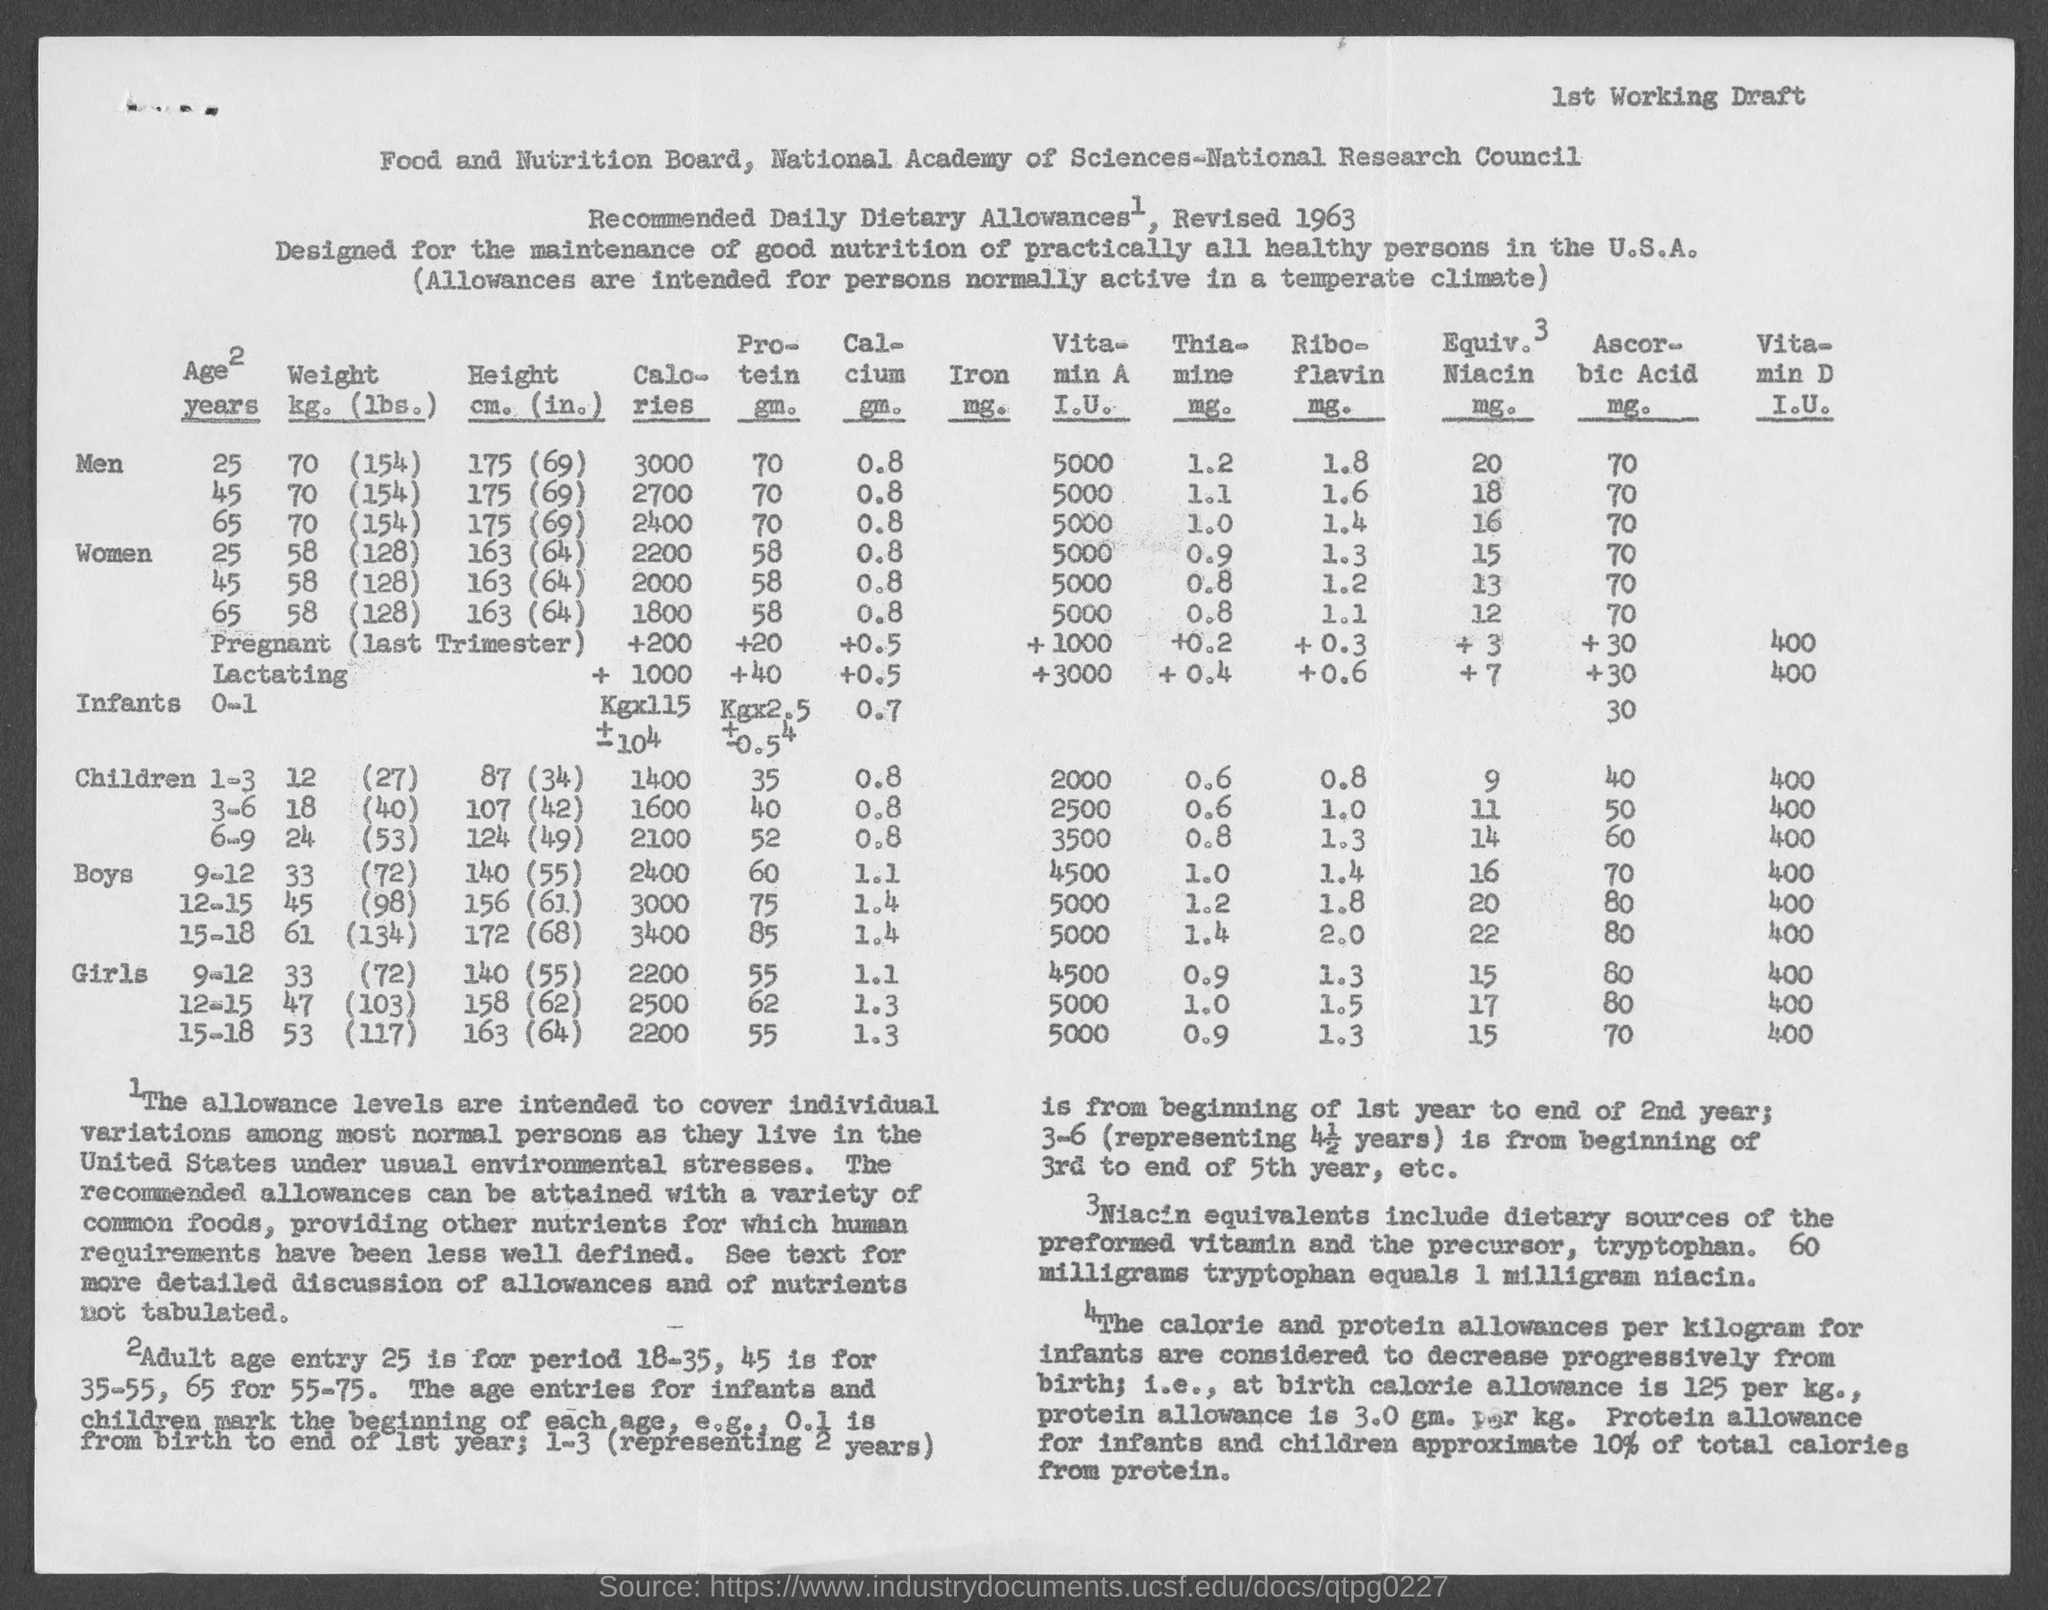Identify some key points in this picture. The revised "Recommended Daily Dietary Allowances" were published in 1963. The recommended amount of protein at birth is 3.0 grams per kilogram of body weight. There are 60 milligrams of tryptophan in 1 milligram of niacin. The "Adult age entry" for the period 35-55 is 45 years old. The document's heading is titled 'Food and Nutrition Board, National Academy of Sciences-National Research Council.' 